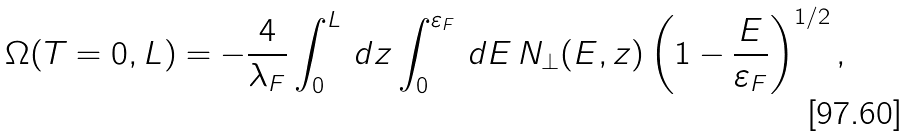<formula> <loc_0><loc_0><loc_500><loc_500>\Omega ( T = 0 , L ) = - \frac { 4 } { \lambda _ { F } } \int _ { 0 } ^ { L } \, d z \int _ { 0 } ^ { \varepsilon _ { F } } \, d E \, N _ { \perp } ( E , z ) \left ( 1 - \frac { E } { \varepsilon _ { F } } \right ) ^ { 1 / 2 } ,</formula> 